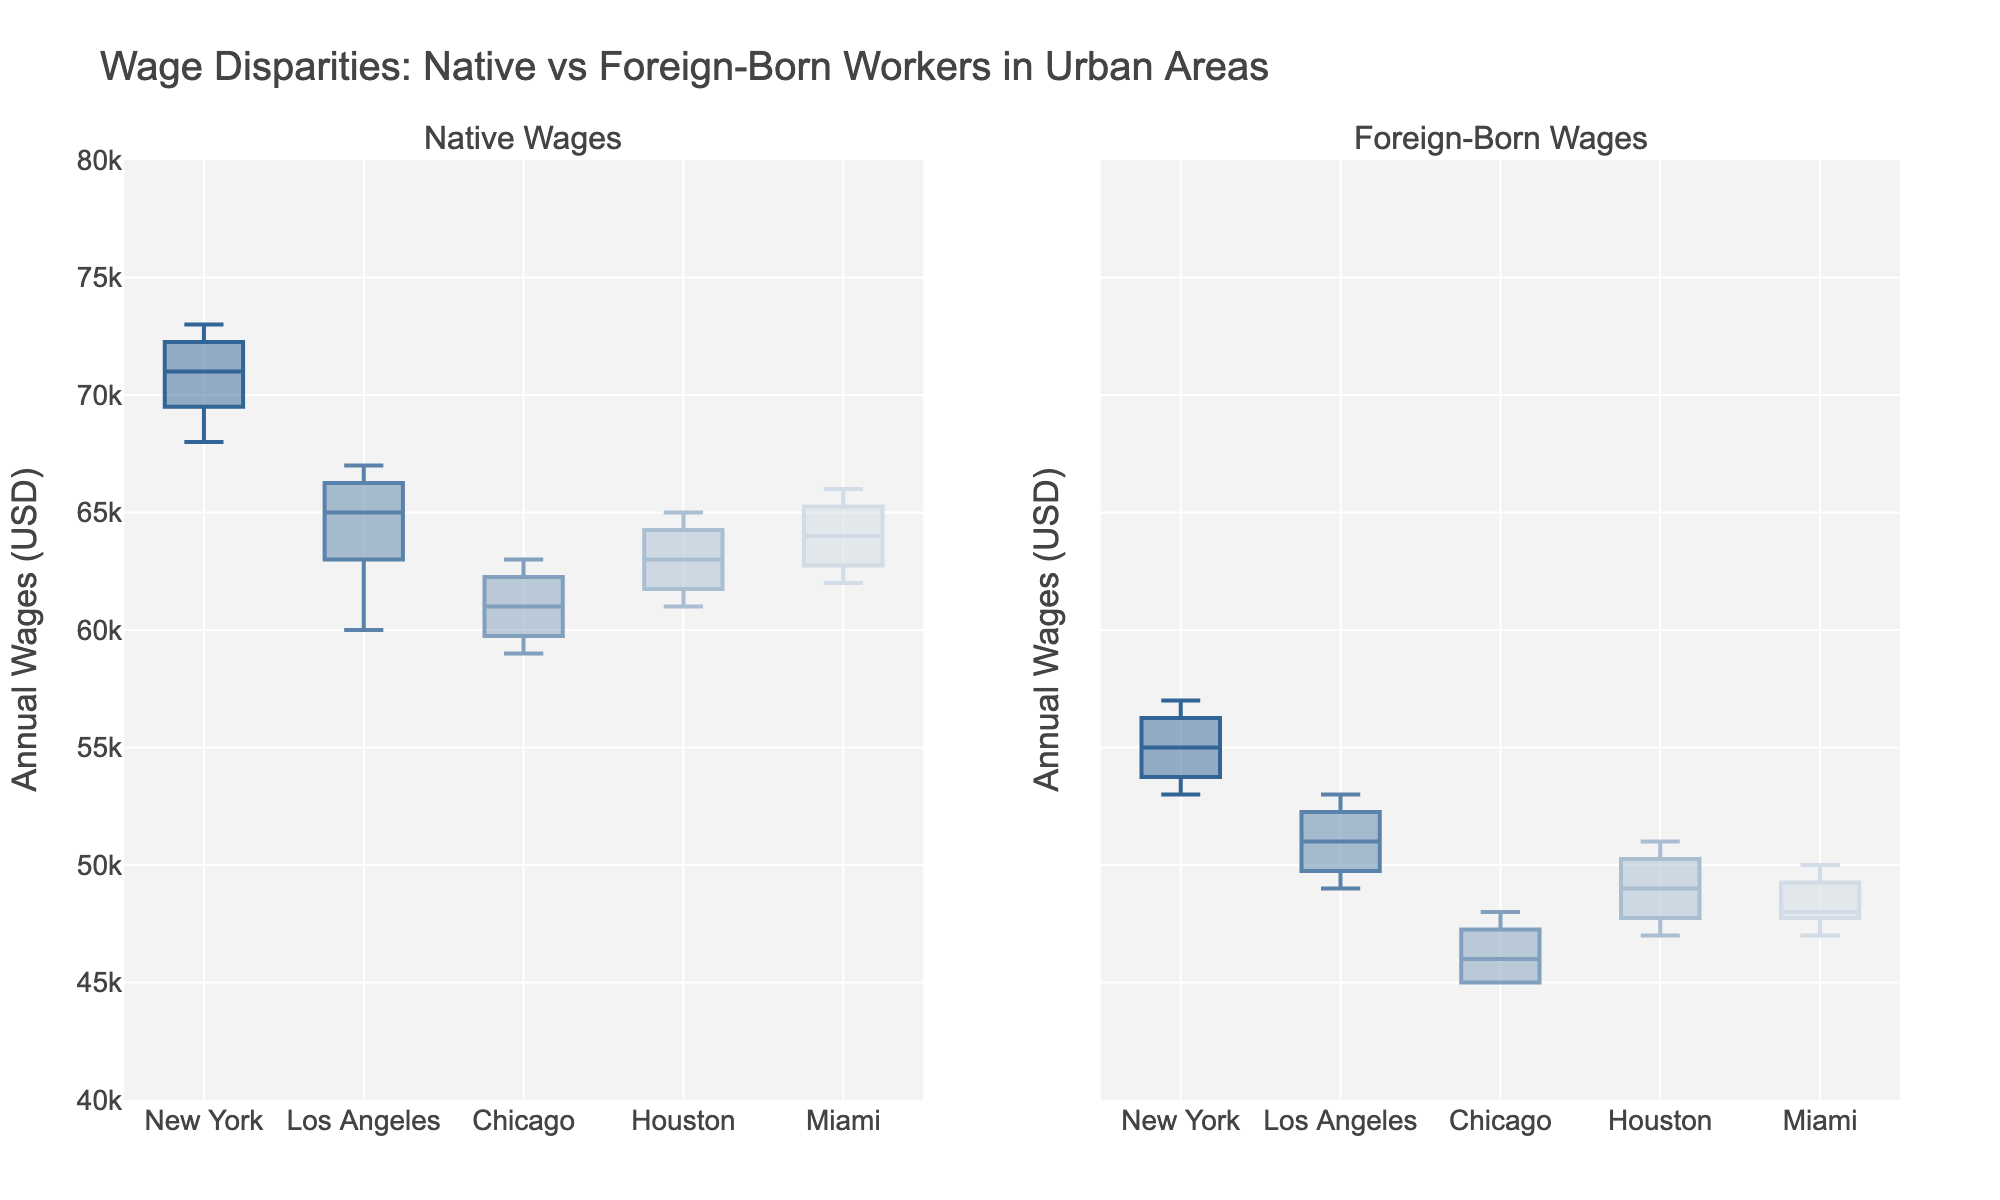What is the title of the figure? The title is typically found at the top of the figure and usually summarizes the content and purpose of the plot.
Answer: Wage Disparities: Native vs Foreign-Born Workers in Urban Areas Which city shows the highest median wage for native workers? To determine the highest median wage for native workers, inspect the central line of the box (median) for each city on the left subplot and identify the tallest one.
Answer: New York Compare the median wages of native workers and foreign-born workers in Los Angeles. Which is higher? Look at the central lines in the box plots for Los Angeles in both subplots and compare their positions; the one higher up represents a higher median wage.
Answer: Native workers What are the interquartile ranges (IQR) of wages for foreign-born workers in Houston? The IQR is the distance between the first quartile (the bottom of the box) and the third quartile (the top of the box). Visually measure the distance between these two points on the foreign-born workers' box plot for Houston on the right subplot.
Answer: Approximately 40,000 - 50,000 Which city has the smallest wage range for foreign-born workers, and what is it? The wage range can be determined by the distance between the whiskers (minimum and maximum values) in the box plots. Compare the whisker lengths across cities on the right subplot.
Answer: Chicago, 45000 - 48000 Is there any city where the median wage for foreign-born workers is higher than for native workers? Inspect and compare the median lines of the corresponding box plots for each city in both subplots.
Answer: No Which city has the greatest variability in wages for native workers? Variability is indicated by the distance between the whiskers in the box plot. Measure which city has the largest distance on the left subplot.
Answer: Los Angeles What is the median wage for foreign-born workers in Miami? The median wage is represented by the central line within the box for Miami in the right subplot.
Answer: Approximately 48000 How do the interquartile ranges (IQR) of native wages in Chicago compare to those in Miami? Calculate the IQR by finding the difference between the third quartile and first quartile for native wages in both Chicago and Miami in the left subplot. Compare these two values.
Answer: Chicago: approximately 60000 - 62000, Miami: approximately 63000 - 65000 Compare the wage range for native workers in New York to that of Houston. Which city has a wider range? The wage range is the distance between the minimum and maximum values in the box plots. Compare these ranges for native workers in New York and Houston on the left subplot.
Answer: New York 